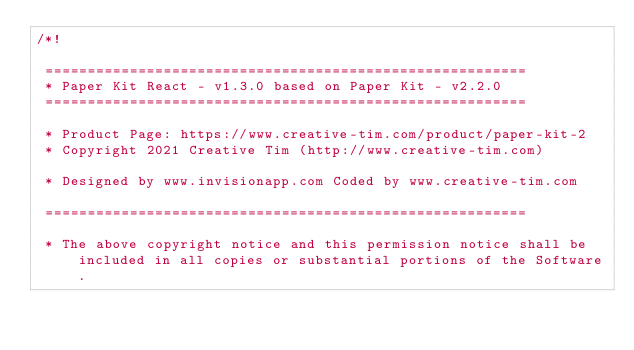Convert code to text. <code><loc_0><loc_0><loc_500><loc_500><_CSS_>/*!

 =========================================================
 * Paper Kit React - v1.3.0 based on Paper Kit - v2.2.0
 =========================================================

 * Product Page: https://www.creative-tim.com/product/paper-kit-2
 * Copyright 2021 Creative Tim (http://www.creative-tim.com)

 * Designed by www.invisionapp.com Coded by www.creative-tim.com

 =========================================================

 * The above copyright notice and this permission notice shall be included in all copies or substantial portions of the Software.
</code> 